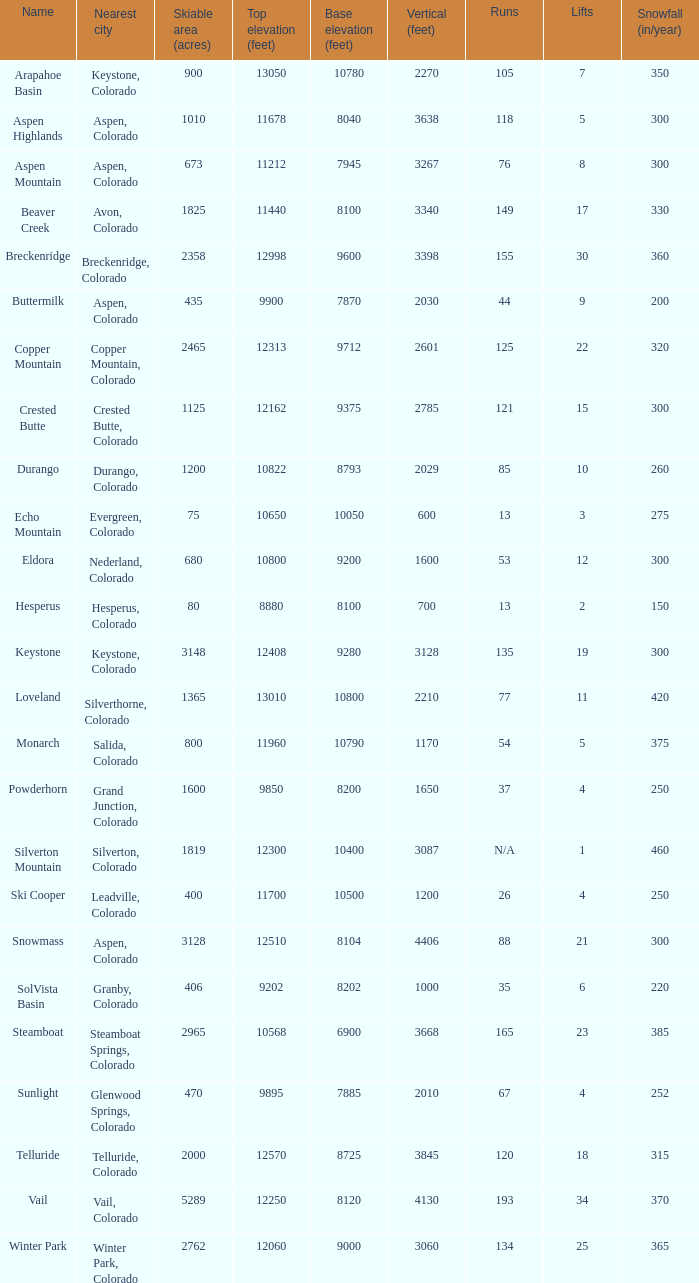If there are 30 lifts, what is the name of the ski resort? Breckenridge. Help me parse the entirety of this table. {'header': ['Name', 'Nearest city', 'Skiable area (acres)', 'Top elevation (feet)', 'Base elevation (feet)', 'Vertical (feet)', 'Runs', 'Lifts', 'Snowfall (in/year)'], 'rows': [['Arapahoe Basin', 'Keystone, Colorado', '900', '13050', '10780', '2270', '105', '7', '350'], ['Aspen Highlands', 'Aspen, Colorado', '1010', '11678', '8040', '3638', '118', '5', '300'], ['Aspen Mountain', 'Aspen, Colorado', '673', '11212', '7945', '3267', '76', '8', '300'], ['Beaver Creek', 'Avon, Colorado', '1825', '11440', '8100', '3340', '149', '17', '330'], ['Breckenridge', 'Breckenridge, Colorado', '2358', '12998', '9600', '3398', '155', '30', '360'], ['Buttermilk', 'Aspen, Colorado', '435', '9900', '7870', '2030', '44', '9', '200'], ['Copper Mountain', 'Copper Mountain, Colorado', '2465', '12313', '9712', '2601', '125', '22', '320'], ['Crested Butte', 'Crested Butte, Colorado', '1125', '12162', '9375', '2785', '121', '15', '300'], ['Durango', 'Durango, Colorado', '1200', '10822', '8793', '2029', '85', '10', '260'], ['Echo Mountain', 'Evergreen, Colorado', '75', '10650', '10050', '600', '13', '3', '275'], ['Eldora', 'Nederland, Colorado', '680', '10800', '9200', '1600', '53', '12', '300'], ['Hesperus', 'Hesperus, Colorado', '80', '8880', '8100', '700', '13', '2', '150'], ['Keystone', 'Keystone, Colorado', '3148', '12408', '9280', '3128', '135', '19', '300'], ['Loveland', 'Silverthorne, Colorado', '1365', '13010', '10800', '2210', '77', '11', '420'], ['Monarch', 'Salida, Colorado', '800', '11960', '10790', '1170', '54', '5', '375'], ['Powderhorn', 'Grand Junction, Colorado', '1600', '9850', '8200', '1650', '37', '4', '250'], ['Silverton Mountain', 'Silverton, Colorado', '1819', '12300', '10400', '3087', 'N/A', '1', '460'], ['Ski Cooper', 'Leadville, Colorado', '400', '11700', '10500', '1200', '26', '4', '250'], ['Snowmass', 'Aspen, Colorado', '3128', '12510', '8104', '4406', '88', '21', '300'], ['SolVista Basin', 'Granby, Colorado', '406', '9202', '8202', '1000', '35', '6', '220'], ['Steamboat', 'Steamboat Springs, Colorado', '2965', '10568', '6900', '3668', '165', '23', '385'], ['Sunlight', 'Glenwood Springs, Colorado', '470', '9895', '7885', '2010', '67', '4', '252'], ['Telluride', 'Telluride, Colorado', '2000', '12570', '8725', '3845', '120', '18', '315'], ['Vail', 'Vail, Colorado', '5289', '12250', '8120', '4130', '193', '34', '370'], ['Winter Park', 'Winter Park, Colorado', '2762', '12060', '9000', '3060', '134', '25', '365']]} 